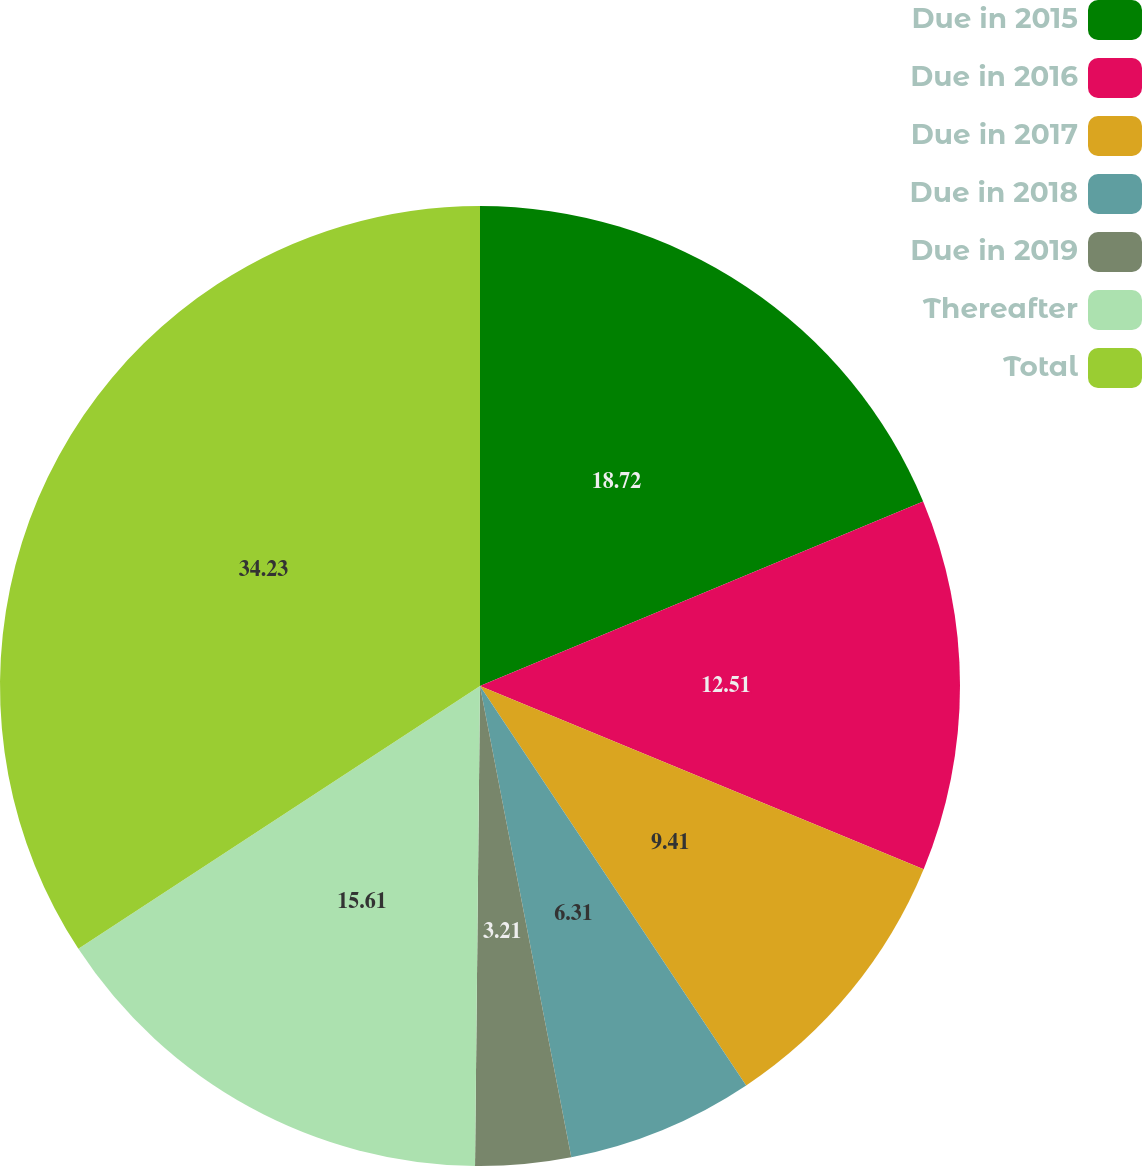<chart> <loc_0><loc_0><loc_500><loc_500><pie_chart><fcel>Due in 2015<fcel>Due in 2016<fcel>Due in 2017<fcel>Due in 2018<fcel>Due in 2019<fcel>Thereafter<fcel>Total<nl><fcel>18.72%<fcel>12.51%<fcel>9.41%<fcel>6.31%<fcel>3.21%<fcel>15.61%<fcel>34.22%<nl></chart> 